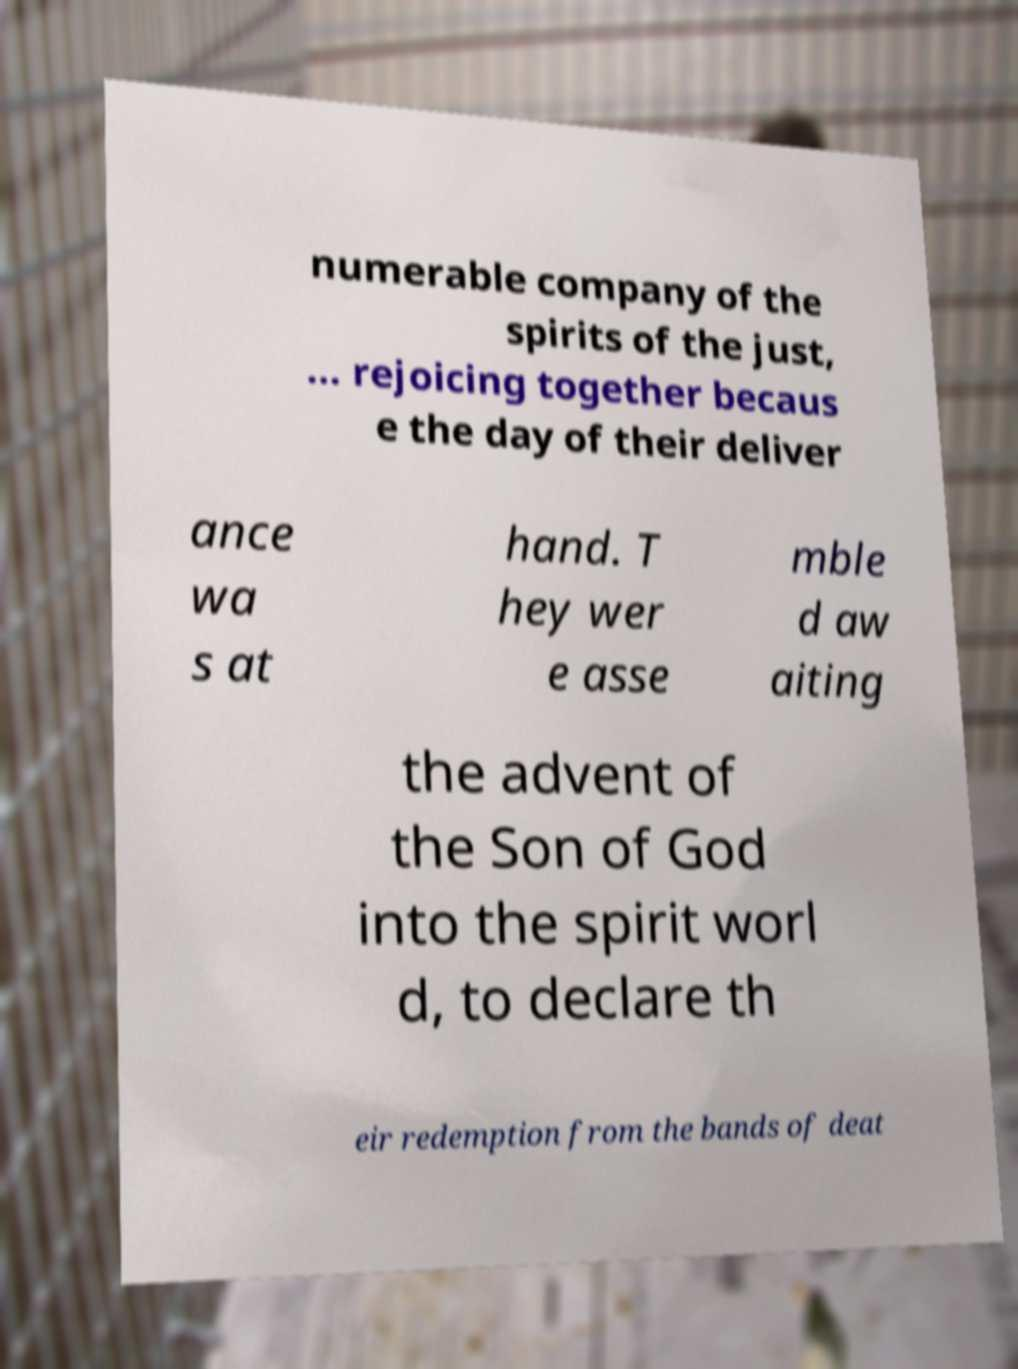I need the written content from this picture converted into text. Can you do that? numerable company of the spirits of the just, ... rejoicing together becaus e the day of their deliver ance wa s at hand. T hey wer e asse mble d aw aiting the advent of the Son of God into the spirit worl d, to declare th eir redemption from the bands of deat 